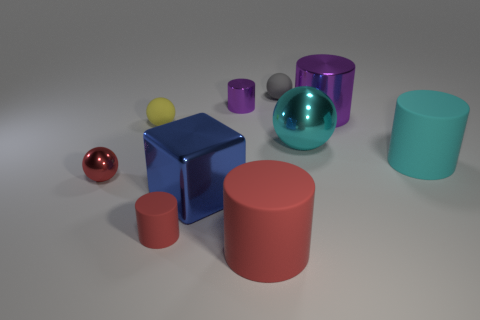Are there fewer small red cylinders than big cyan shiny cylinders?
Provide a succinct answer. No. Are there any big cylinders that have the same color as the small shiny cylinder?
Ensure brevity in your answer.  Yes. There is a big thing that is both in front of the cyan matte object and right of the metallic cube; what is its shape?
Your response must be concise. Cylinder. The tiny rubber thing that is in front of the matte thing that is on the right side of the tiny gray rubber sphere is what shape?
Provide a short and direct response. Cylinder. Is the yellow matte thing the same shape as the tiny gray thing?
Ensure brevity in your answer.  Yes. There is a small sphere that is the same color as the tiny rubber cylinder; what is it made of?
Offer a terse response. Metal. Is the color of the small shiny cylinder the same as the big metallic cylinder?
Give a very brief answer. Yes. There is a tiny rubber thing that is in front of the yellow matte thing that is behind the blue block; how many red matte cylinders are behind it?
Your response must be concise. 0. What is the shape of the big red object that is made of the same material as the big cyan cylinder?
Provide a succinct answer. Cylinder. What is the material of the big cyan object that is left of the large metallic thing to the right of the large cyan sphere left of the cyan rubber cylinder?
Offer a very short reply. Metal. 